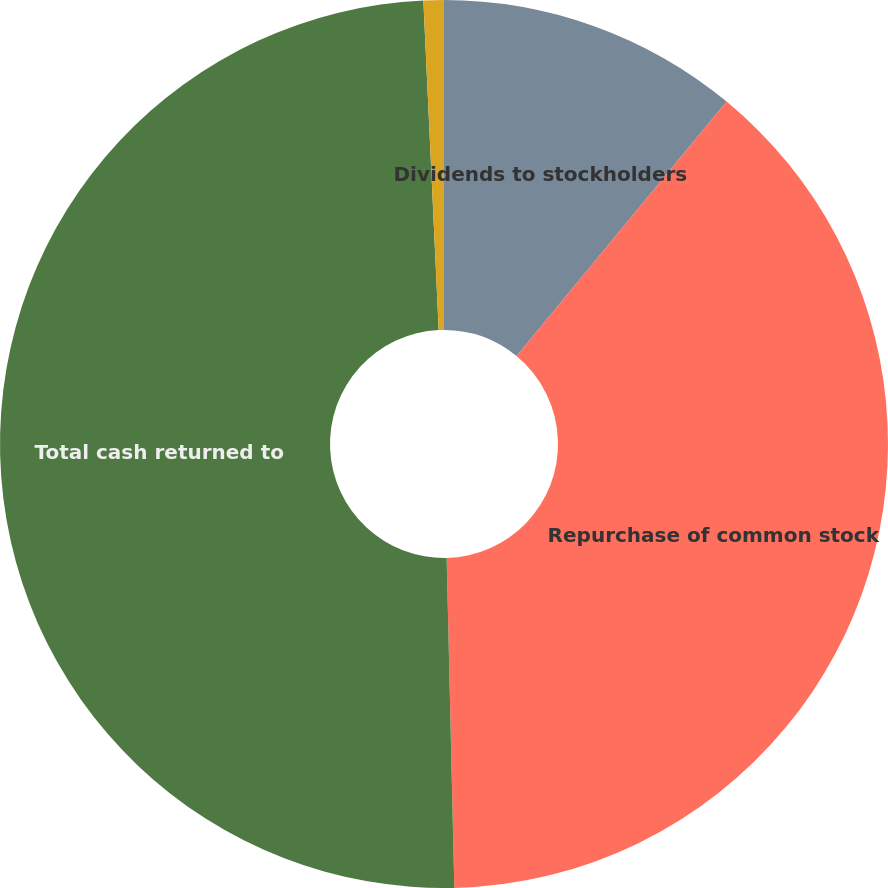Convert chart to OTSL. <chart><loc_0><loc_0><loc_500><loc_500><pie_chart><fcel>Dividends to stockholders<fcel>Repurchase of common stock<fcel>Total cash returned to<fcel>Number of shares repurchased<nl><fcel>10.98%<fcel>38.65%<fcel>49.63%<fcel>0.74%<nl></chart> 